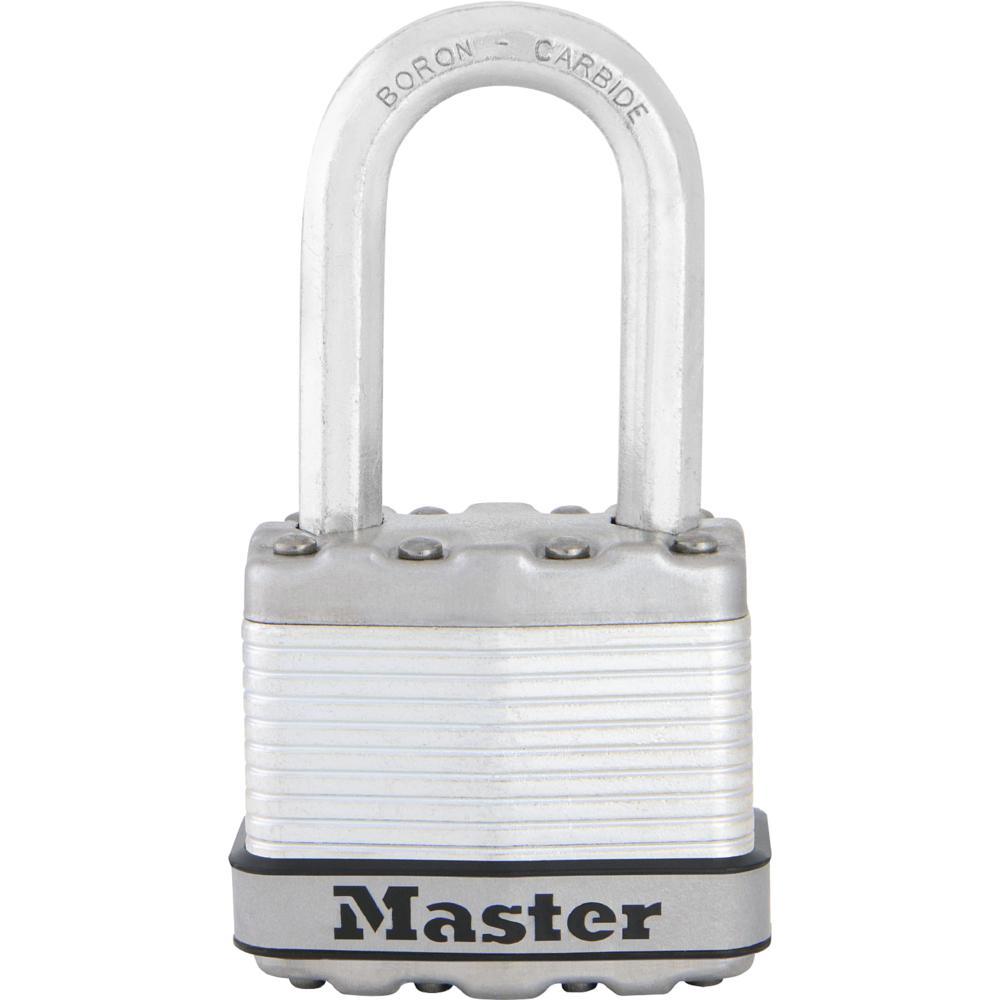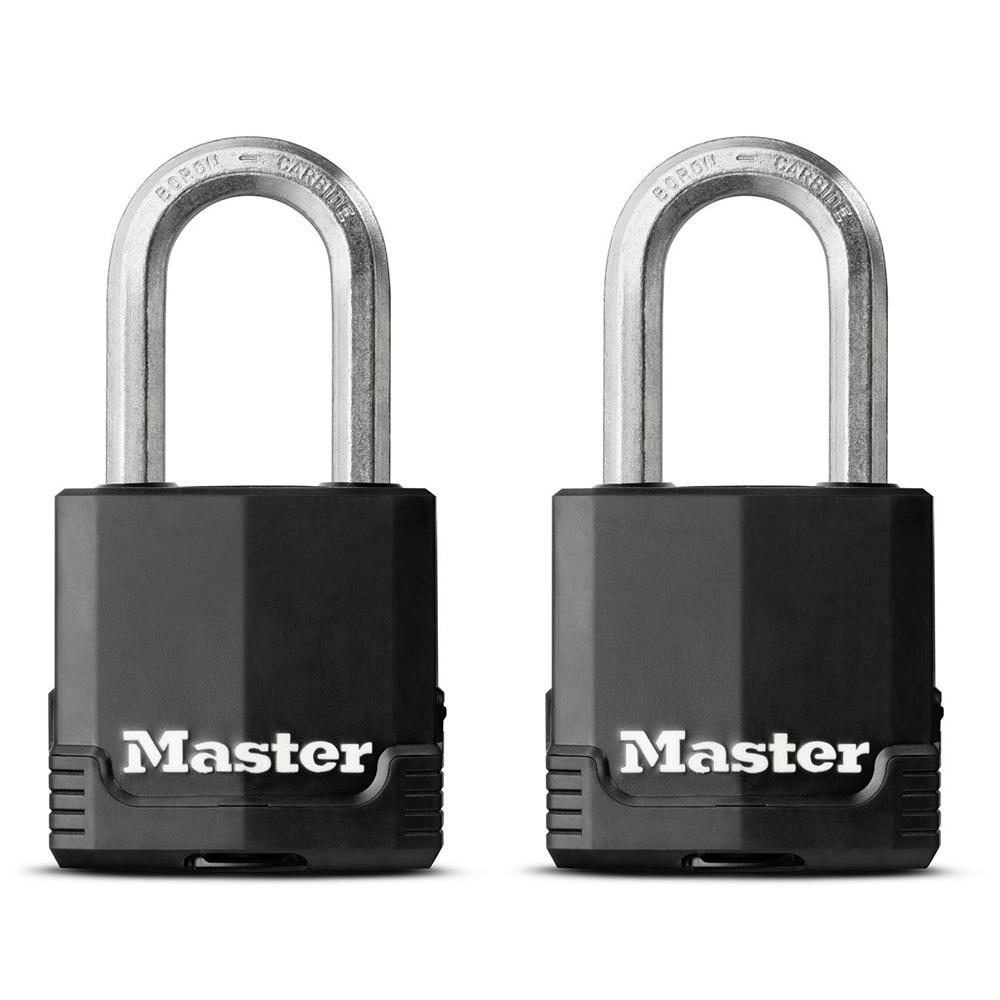The first image is the image on the left, the second image is the image on the right. Analyze the images presented: Is the assertion "there are two keys next to a lock" valid? Answer yes or no. No. The first image is the image on the left, the second image is the image on the right. Analyze the images presented: Is the assertion "There is a pair of gold colored keys beside a lock in one of the images." valid? Answer yes or no. No. 